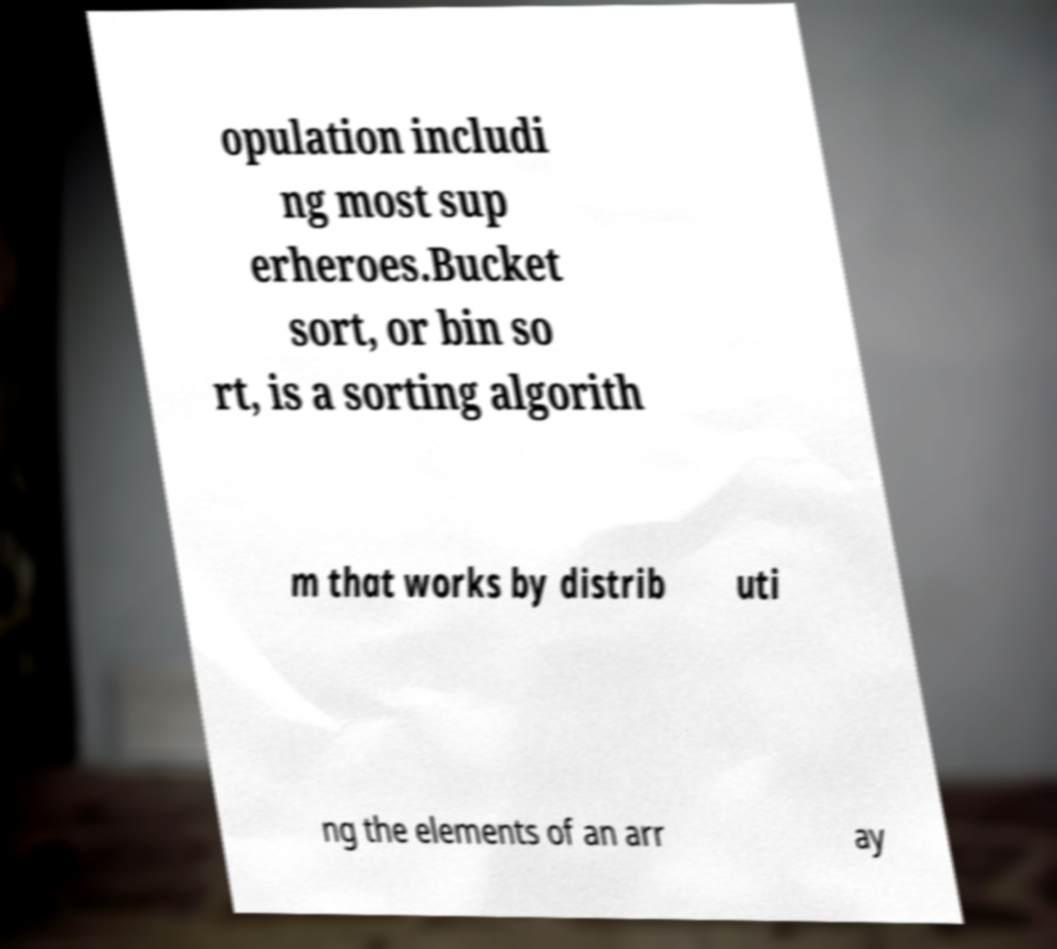There's text embedded in this image that I need extracted. Can you transcribe it verbatim? opulation includi ng most sup erheroes.Bucket sort, or bin so rt, is a sorting algorith m that works by distrib uti ng the elements of an arr ay 